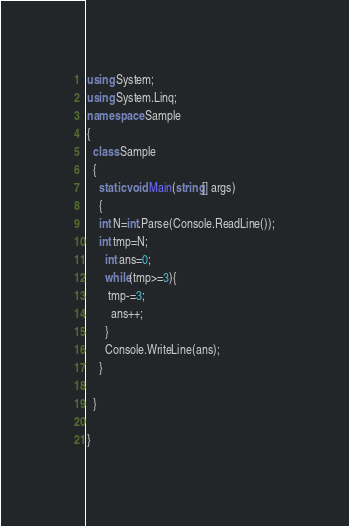<code> <loc_0><loc_0><loc_500><loc_500><_C#_>using System;
using System.Linq;
namespace Sample
{
  class Sample
  {
    static void Main(string[] args)
    {
    int N=int.Parse(Console.ReadLine());
    int tmp=N;
      int ans=0;
      while(tmp>=3){
       tmp-=3;
        ans++;
      }
      Console.WriteLine(ans);
    }
    
  }

}
</code> 